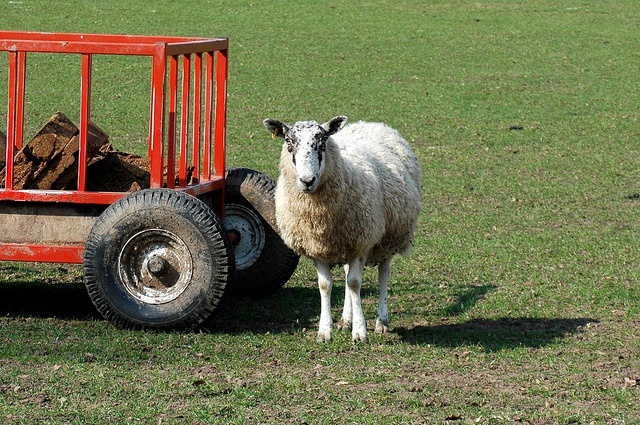Describe the objects in this image and their specific colors. I can see truck in green, black, gray, red, and olive tones and sheep in green, gray, ivory, black, and darkgray tones in this image. 